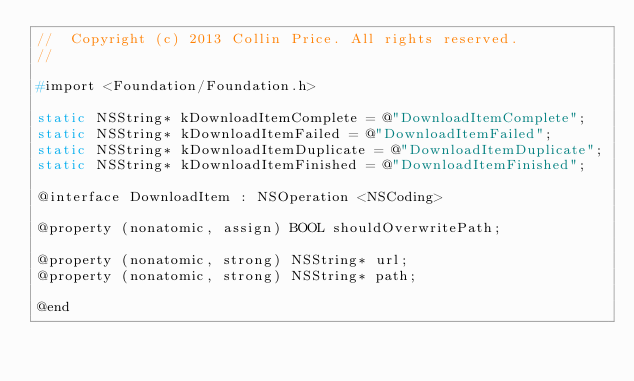<code> <loc_0><loc_0><loc_500><loc_500><_C_>//  Copyright (c) 2013 Collin Price. All rights reserved.
//

#import <Foundation/Foundation.h>

static NSString* kDownloadItemComplete = @"DownloadItemComplete";
static NSString* kDownloadItemFailed = @"DownloadItemFailed";
static NSString* kDownloadItemDuplicate = @"DownloadItemDuplicate";
static NSString* kDownloadItemFinished = @"DownloadItemFinished";

@interface DownloadItem : NSOperation <NSCoding>

@property (nonatomic, assign) BOOL shouldOverwritePath;

@property (nonatomic, strong) NSString* url;
@property (nonatomic, strong) NSString* path;

@end
</code> 